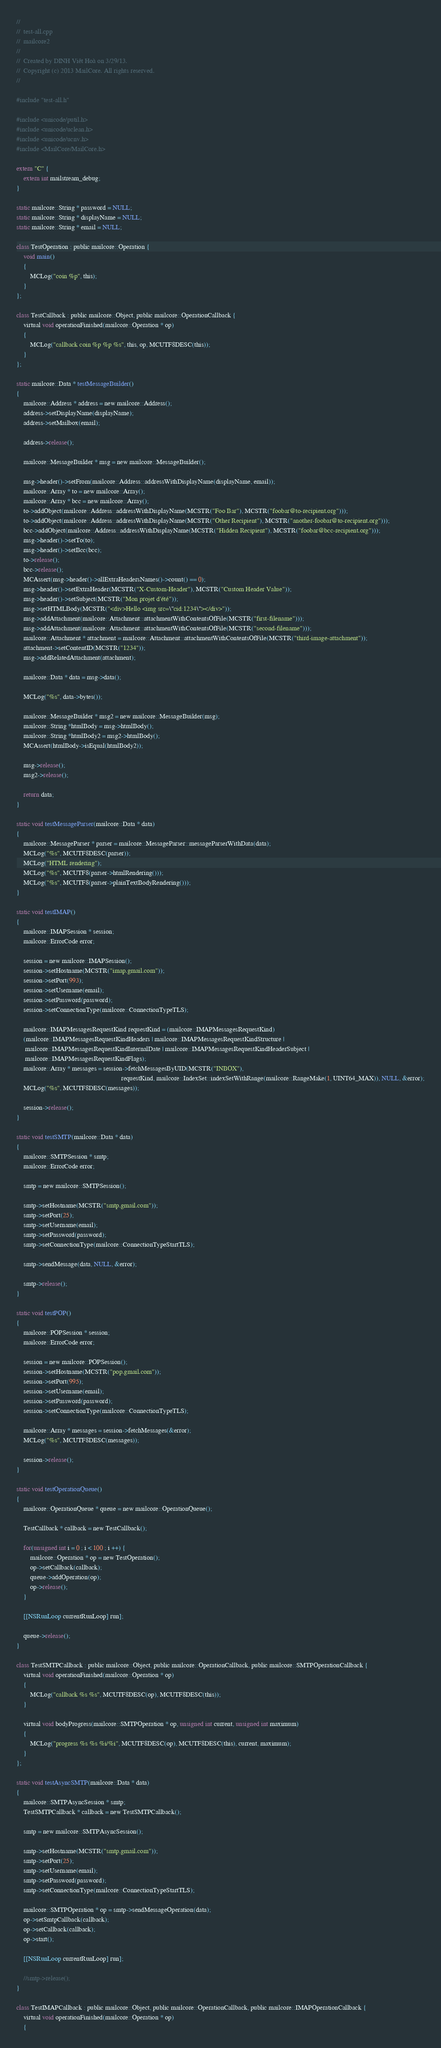<code> <loc_0><loc_0><loc_500><loc_500><_ObjectiveC_>//
//  test-all.cpp
//  mailcore2
//
//  Created by DINH Viêt Hoà on 3/29/13.
//  Copyright (c) 2013 MailCore. All rights reserved.
//

#include "test-all.h"

#include <unicode/putil.h>
#include <unicode/uclean.h>
#include <unicode/ucnv.h>
#include <MailCore/MailCore.h>

extern "C" {
    extern int mailstream_debug;
}

static mailcore::String * password = NULL;
static mailcore::String * displayName = NULL;
static mailcore::String * email = NULL;

class TestOperation : public mailcore::Operation {
	void main()
	{
		MCLog("coin %p", this);
	}
};

class TestCallback : public mailcore::Object, public mailcore::OperationCallback {
	virtual void operationFinished(mailcore::Operation * op)
	{
		MCLog("callback coin %p %p %s", this, op, MCUTF8DESC(this));
	}
};

static mailcore::Data * testMessageBuilder()
{
    mailcore::Address * address = new mailcore::Address();
    address->setDisplayName(displayName);
    address->setMailbox(email);
    
    address->release();
    
    mailcore::MessageBuilder * msg = new mailcore::MessageBuilder();
    
    msg->header()->setFrom(mailcore::Address::addressWithDisplayName(displayName, email));
    mailcore::Array * to = new mailcore::Array();
    mailcore::Array * bcc = new mailcore::Array();
    to->addObject(mailcore::Address::addressWithDisplayName(MCSTR("Foo Bar"), MCSTR("foobar@to-recipient.org")));
    to->addObject(mailcore::Address::addressWithDisplayName(MCSTR("Other Recipient"), MCSTR("another-foobar@to-recipient.org")));
    bcc->addObject(mailcore::Address::addressWithDisplayName(MCSTR("Hidden Recipient"), MCSTR("foobar@bcc-recipient.org")));
    msg->header()->setTo(to);
    msg->header()->setBcc(bcc);
    to->release();
    bcc->release();
    MCAssert(msg->header()->allExtraHeadersNames()->count() == 0);
    msg->header()->setExtraHeader(MCSTR("X-Custom-Header"), MCSTR("Custom Header Value"));
    msg->header()->setSubject(MCSTR("Mon projet d'été"));
    msg->setHTMLBody(MCSTR("<div>Hello <img src=\"cid:1234\"></div>"));
    msg->addAttachment(mailcore::Attachment::attachmentWithContentsOfFile(MCSTR("first-filename")));
    msg->addAttachment(mailcore::Attachment::attachmentWithContentsOfFile(MCSTR("second-filename")));
    mailcore::Attachment * attachment = mailcore::Attachment::attachmentWithContentsOfFile(MCSTR("third-image-attachment"));
    attachment->setContentID(MCSTR("1234"));
    msg->addRelatedAttachment(attachment);
    
    mailcore::Data * data = msg->data();
    
    MCLog("%s", data->bytes());
    
    mailcore::MessageBuilder * msg2 = new mailcore::MessageBuilder(msg);
    mailcore::String *htmlBody = msg->htmlBody();
    mailcore::String *htmlBody2 = msg2->htmlBody();
    MCAssert(htmlBody->isEqual(htmlBody2));
    
    msg->release();
    msg2->release();
    
    return data;
}

static void testMessageParser(mailcore::Data * data)
{
    mailcore::MessageParser * parser = mailcore::MessageParser::messageParserWithData(data);
    MCLog("%s", MCUTF8DESC(parser));
    MCLog("HTML rendering");
    MCLog("%s", MCUTF8(parser->htmlRendering()));
    MCLog("%s", MCUTF8(parser->plainTextBodyRendering()));
}

static void testIMAP()
{
    mailcore::IMAPSession * session;
    mailcore::ErrorCode error;
    
    session = new mailcore::IMAPSession();
    session->setHostname(MCSTR("imap.gmail.com"));
    session->setPort(993);
    session->setUsername(email);
    session->setPassword(password);
    session->setConnectionType(mailcore::ConnectionTypeTLS);
    
    mailcore::IMAPMessagesRequestKind requestKind = (mailcore::IMAPMessagesRequestKind)
    (mailcore::IMAPMessagesRequestKindHeaders | mailcore::IMAPMessagesRequestKindStructure |
     mailcore::IMAPMessagesRequestKindInternalDate | mailcore::IMAPMessagesRequestKindHeaderSubject |
     mailcore::IMAPMessagesRequestKindFlags);
    mailcore::Array * messages = session->fetchMessagesByUID(MCSTR("INBOX"),
                                                             requestKind, mailcore::IndexSet::indexSetWithRange(mailcore::RangeMake(1, UINT64_MAX)), NULL, &error);
    MCLog("%s", MCUTF8DESC(messages));
    
    session->release();
}

static void testSMTP(mailcore::Data * data)
{
    mailcore::SMTPSession * smtp;
    mailcore::ErrorCode error;
    
    smtp = new mailcore::SMTPSession();
    
    smtp->setHostname(MCSTR("smtp.gmail.com"));
    smtp->setPort(25);
    smtp->setUsername(email);
    smtp->setPassword(password);
    smtp->setConnectionType(mailcore::ConnectionTypeStartTLS);
    
    smtp->sendMessage(data, NULL, &error);
    
    smtp->release();
}

static void testPOP()
{
    mailcore::POPSession * session;
    mailcore::ErrorCode error;
    
    session = new mailcore::POPSession();
    session->setHostname(MCSTR("pop.gmail.com"));
    session->setPort(995);
    session->setUsername(email);
    session->setPassword(password);
    session->setConnectionType(mailcore::ConnectionTypeTLS);
    
    mailcore::Array * messages = session->fetchMessages(&error);
    MCLog("%s", MCUTF8DESC(messages));
    
    session->release();
}

static void testOperationQueue()
{
    mailcore::OperationQueue * queue = new mailcore::OperationQueue();
    
	TestCallback * callback = new TestCallback();
	
    for(unsigned int i = 0 ; i < 100 ; i ++) {
        mailcore::Operation * op = new TestOperation();
		op->setCallback(callback);
        queue->addOperation(op);
        op->release();
    }
    
    [[NSRunLoop currentRunLoop] run];
    
    queue->release();
}

class TestSMTPCallback : public mailcore::Object, public mailcore::OperationCallback, public mailcore::SMTPOperationCallback {
	virtual void operationFinished(mailcore::Operation * op)
	{
		MCLog("callback %s %s", MCUTF8DESC(op), MCUTF8DESC(this));
	}
    
    virtual void bodyProgress(mailcore::SMTPOperation * op, unsigned int current, unsigned int maximum)
    {
		MCLog("progress %s %s %i/%i", MCUTF8DESC(op), MCUTF8DESC(this), current, maximum);
    }
};

static void testAsyncSMTP(mailcore::Data * data)
{
    mailcore::SMTPAsyncSession * smtp;
    TestSMTPCallback * callback = new TestSMTPCallback();
    
    smtp = new mailcore::SMTPAsyncSession();
    
    smtp->setHostname(MCSTR("smtp.gmail.com"));
    smtp->setPort(25);
    smtp->setUsername(email);
    smtp->setPassword(password);
    smtp->setConnectionType(mailcore::ConnectionTypeStartTLS);
    
    mailcore::SMTPOperation * op = smtp->sendMessageOperation(data);
    op->setSmtpCallback(callback);
    op->setCallback(callback);
    op->start();
    
    [[NSRunLoop currentRunLoop] run];
    
    //smtp->release();
}

class TestIMAPCallback : public mailcore::Object, public mailcore::OperationCallback, public mailcore::IMAPOperationCallback {
	virtual void operationFinished(mailcore::Operation * op)
	{</code> 